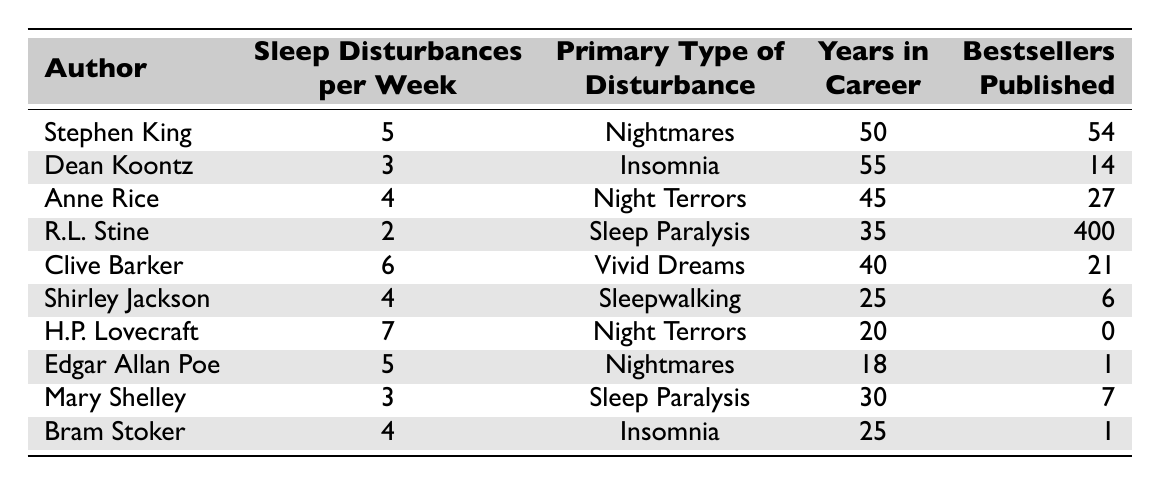What is the primary type of sleep disturbance experienced by Clive Barker? Referring to the table, Clive Barker’s primary type of sleep disturbance is listed directly across from his name.
Answer: Vivid Dreams How many years of career does Stephen King have? The table entry for Stephen King shows that he has 50 years in his career.
Answer: 50 Which author has the highest number of sleep disturbances per week? By comparing the "Sleep Disturbances per Week" column, H.P. Lovecraft has the highest value with 7 disturbances.
Answer: H.P. Lovecraft What is the average number of bestsellers published by the authors listed in the table? To find the average, sum the number of bestsellers (54 + 14 + 27 + 400 + 21 + 6 + 0 + 1 + 7 + 1 = 531) and divide by 10 (since there are 10 authors), resulting in an average of 53.1.
Answer: 53.1 Does any author in the table have a primary type of disturbance classified as 'Sleepwalking'? Looking at the "Primary Type of Disturbance" column, Shirley Jackson is listed with this disturbance type. Therefore, the answer is yes.
Answer: Yes Which authors experience nightmares? By scanning the table for the "Primary Type of Disturbance," both Stephen King and Edgar Allan Poe have nightmares as their primary disturbances.
Answer: Stephen King, Edgar Allan Poe What is the difference in sleep disturbances per week between H.P. Lovecraft and R.L. Stine? H.P. Lovecraft has 7 disturbances and R.L. Stine has 2. The difference is calculated as 7 - 2 = 5.
Answer: 5 What percentage of the authors have published more than 20 bestsellers? Four authors (R.L. Stine, Anne Rice, Stephen King, H.P. Lovecraft) have published more than 20 bestsellers out of 10 authors total. So, (4/10) x 100 = 40%.
Answer: 40% How many authors report sleep paralysis as their primary disturbance? Looking across the "Primary Type of Disturbance" column, both R.L. Stine and Mary Shelley report sleep paralysis.
Answer: 2 Is there an author who has published no bestsellers? Examining the "Bestsellers Published" column reveals that H.P. Lovecraft is the only author with 0 bestsellers.
Answer: Yes 